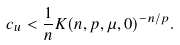Convert formula to latex. <formula><loc_0><loc_0><loc_500><loc_500>c _ { u } < \frac { 1 } { n } K ( n , p , \mu , 0 ) ^ { - n / p } .</formula> 